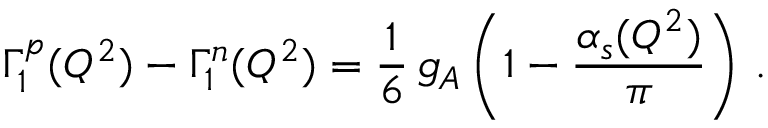Convert formula to latex. <formula><loc_0><loc_0><loc_500><loc_500>\Gamma _ { 1 } ^ { p } ( Q ^ { 2 } ) - \Gamma _ { 1 } ^ { n } ( Q ^ { 2 } ) = \frac { 1 } { 6 } \, g _ { A } \left ( 1 - \frac { \alpha _ { s } ( Q ^ { 2 } ) } { \pi } \right ) \, .</formula> 